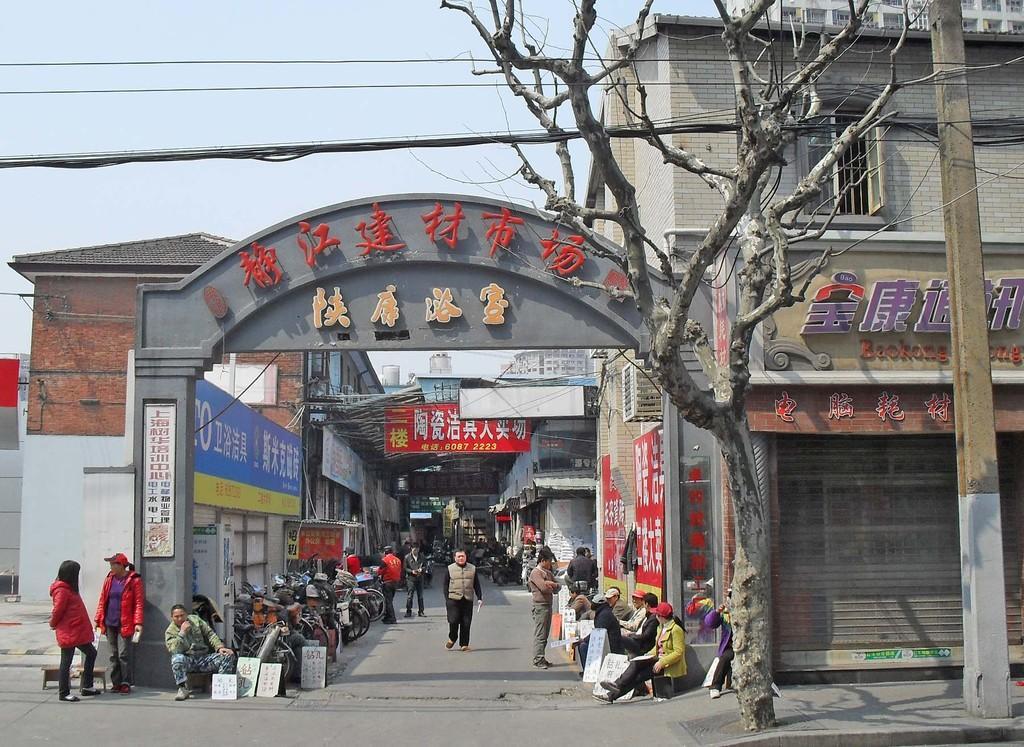How would you summarize this image in a sentence or two? In this image there are buildings and we can see an arch. At the bottom there are people sitting and some of them are standing. There are boards. On the right there is a pole. In the background there is sky and we can see a tree. 